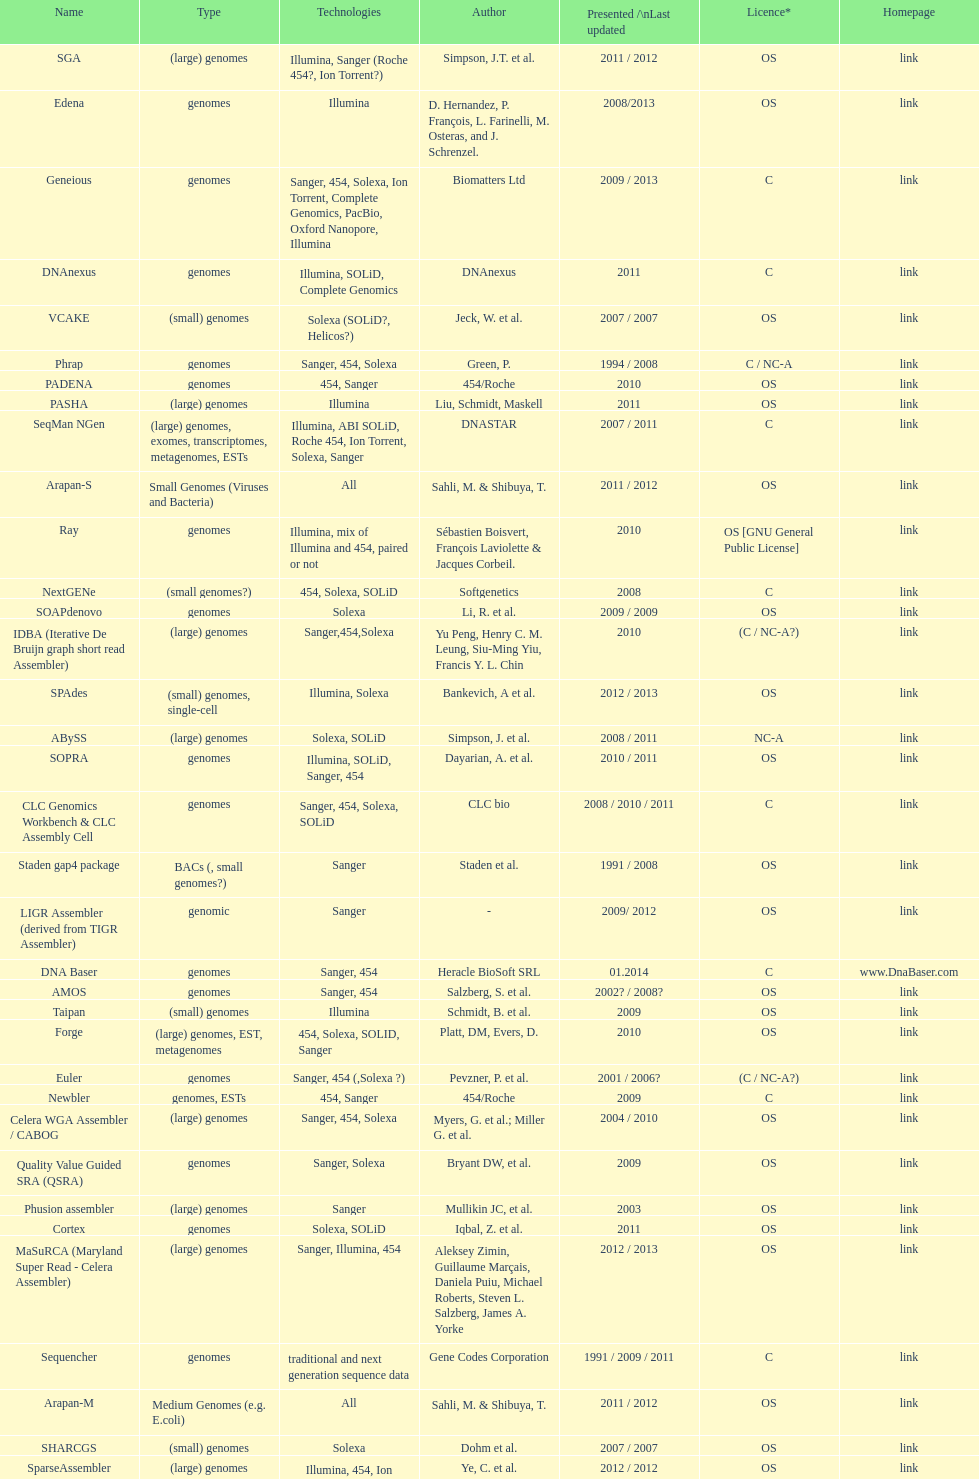Which license is listed more, os or c? OS. 